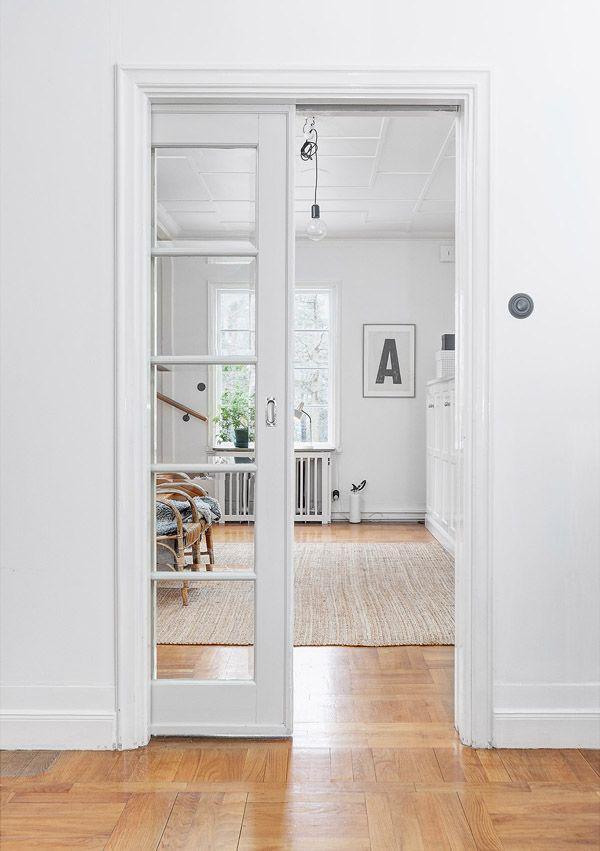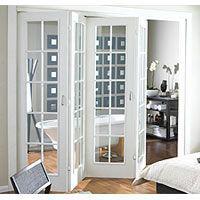The first image is the image on the left, the second image is the image on the right. For the images shown, is this caption "Both doors have less than a 12 inch opening." true? Answer yes or no. No. The first image is the image on the left, the second image is the image on the right. Considering the images on both sides, is "An image shows a door open wide enough to walk through." valid? Answer yes or no. Yes. 